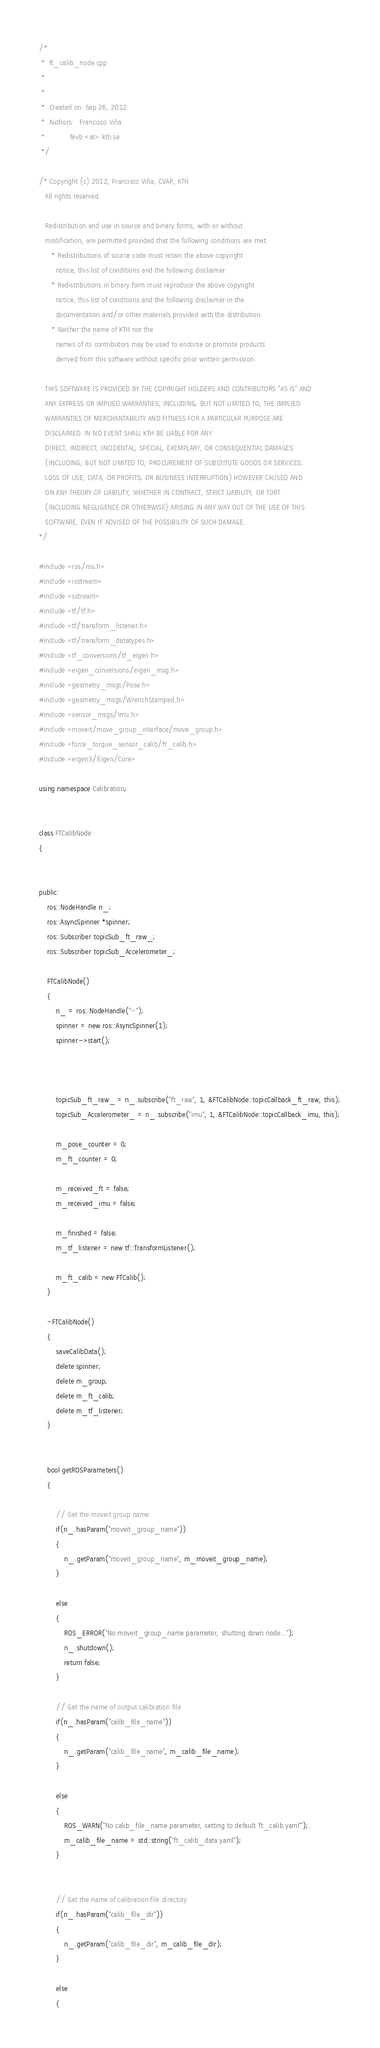<code> <loc_0><loc_0><loc_500><loc_500><_C++_>/*
 *  ft_calib_node.cpp
 *
 *
 *  Created on: Sep 26, 2012
 *  Authors:   Francisco Viña
 *            fevb <at> kth.se
 */

/* Copyright (c) 2012, Francisco Viña, CVAP, KTH
   All rights reserved.

   Redistribution and use in source and binary forms, with or without
   modification, are permitted provided that the following conditions are met:
      * Redistributions of source code must retain the above copyright
        notice, this list of conditions and the following disclaimer.
      * Redistributions in binary form must reproduce the above copyright
        notice, this list of conditions and the following disclaimer in the
        documentation and/or other materials provided with the distribution.
      * Neither the name of KTH nor the
        names of its contributors may be used to endorse or promote products
        derived from this software without specific prior written permission.

   THIS SOFTWARE IS PROVIDED BY THE COPYRIGHT HOLDERS AND CONTRIBUTORS "AS IS" AND
   ANY EXPRESS OR IMPLIED WARRANTIES, INCLUDING, BUT NOT LIMITED TO, THE IMPLIED
   WARRANTIES OF MERCHANTABILITY AND FITNESS FOR A PARTICULAR PURPOSE ARE
   DISCLAIMED. IN NO EVENT SHALL KTH BE LIABLE FOR ANY
   DIRECT, INDIRECT, INCIDENTAL, SPECIAL, EXEMPLARY, OR CONSEQUENTIAL DAMAGES
   (INCLUDING, BUT NOT LIMITED TO, PROCUREMENT OF SUBSTITUTE GOODS OR SERVICES;
   LOSS OF USE, DATA, OR PROFITS; OR BUSINESS INTERRUPTION) HOWEVER CAUSED AND
   ON ANY THEORY OF LIABILITY, WHETHER IN CONTRACT, STRICT LIABILITY, OR TORT
   (INCLUDING NEGLIGENCE OR OTHERWISE) ARISING IN ANY WAY OUT OF THE USE OF THIS
   SOFTWARE, EVEN IF ADVISED OF THE POSSIBILITY OF SUCH DAMAGE.
*/

#include <ros/ros.h>
#include <iostream>
#include <sstream>
#include <tf/tf.h>
#include <tf/transform_listener.h>
#include <tf/transform_datatypes.h>
#include <tf_conversions/tf_eigen.h>
#include <eigen_conversions/eigen_msg.h>
#include <geometry_msgs/Pose.h>
#include <geometry_msgs/WrenchStamped.h>
#include <sensor_msgs/Imu.h>
#include <moveit/move_group_interface/move_group.h>
#include <force_torque_sensor_calib/ft_calib.h>
#include <eigen3/Eigen/Core>

using namespace Calibration;


class FTCalibNode
{


public:
	ros::NodeHandle n_;
	ros::AsyncSpinner *spinner;
	ros::Subscriber topicSub_ft_raw_;
	ros::Subscriber topicSub_Accelerometer_;

	FTCalibNode()
	{
		n_ = ros::NodeHandle("~");
		spinner = new ros::AsyncSpinner(1);
		spinner->start();



		topicSub_ft_raw_ = n_.subscribe("ft_raw", 1, &FTCalibNode::topicCallback_ft_raw, this);
		topicSub_Accelerometer_ = n_.subscribe("imu", 1, &FTCalibNode::topicCallback_imu, this);

		m_pose_counter = 0;
		m_ft_counter = 0;

		m_received_ft = false;
		m_received_imu = false;

		m_finished = false;
		m_tf_listener = new tf::TransformListener();

		m_ft_calib = new FTCalib();
	}

	~FTCalibNode()
	{
		saveCalibData();
		delete spinner;
		delete m_group;
		delete m_ft_calib;
		delete m_tf_listener;
	}


	bool getROSParameters()
	{

		// Get the moveit group name
		if(n_.hasParam("moveit_group_name"))
		{
			n_.getParam("moveit_group_name", m_moveit_group_name);
		}

		else
		{
			ROS_ERROR("No moveit_group_name parameter, shutting down node...");
			n_.shutdown();
			return false;
		}

		// Get the name of output calibration file
		if(n_.hasParam("calib_file_name"))
		{
			n_.getParam("calib_file_name", m_calib_file_name);
		}

		else
		{
			ROS_WARN("No calib_file_name parameter, setting to default 'ft_calib.yaml'");
			m_calib_file_name = std::string("ft_calib_data.yaml");
		}


		// Get the name of calibration file directory
		if(n_.hasParam("calib_file_dir"))
		{
			n_.getParam("calib_file_dir", m_calib_file_dir);
		}

		else
		{</code> 